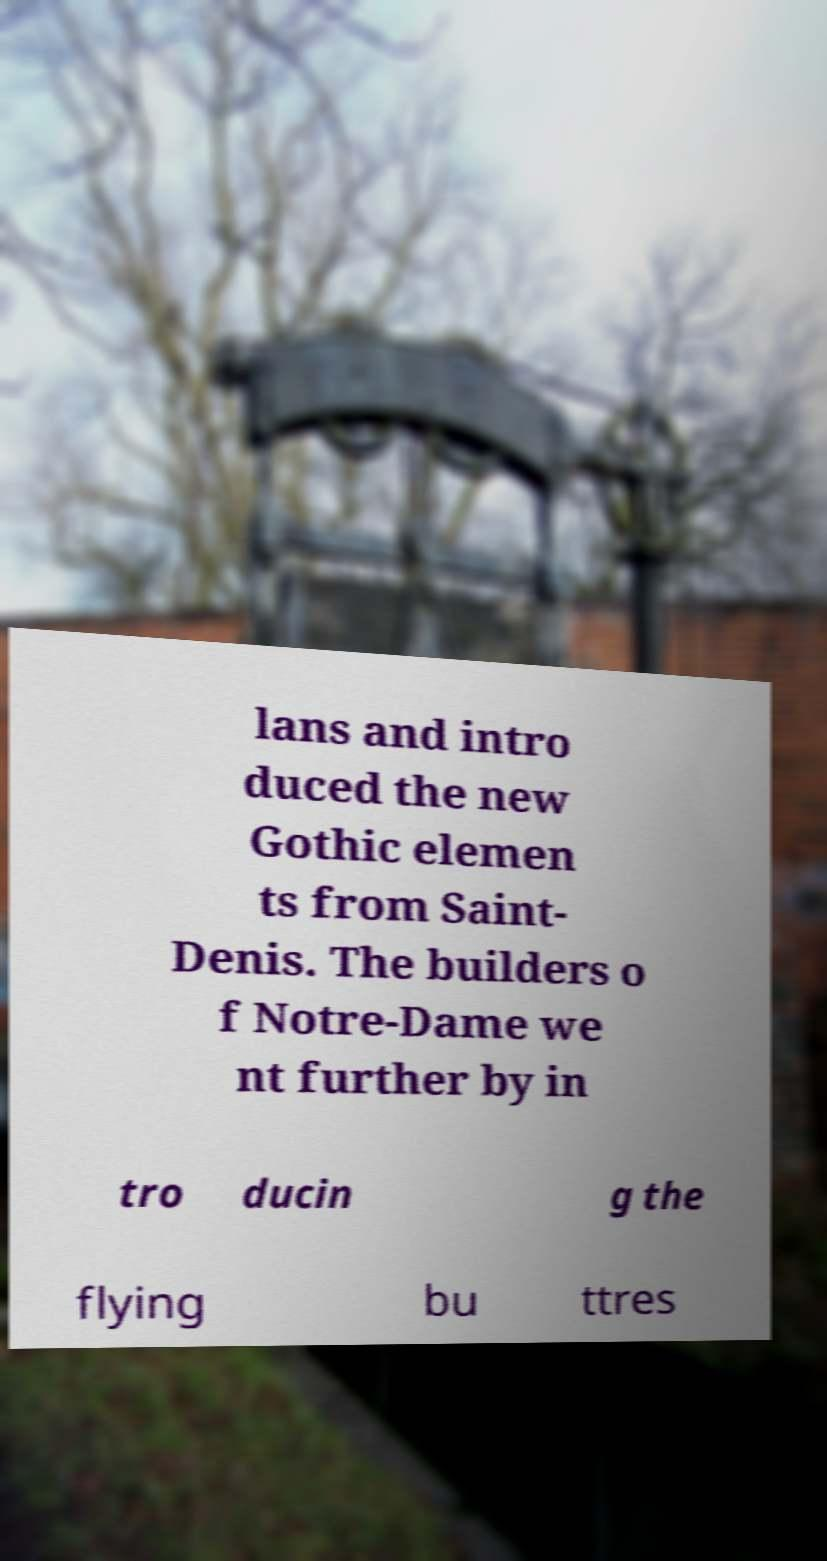What messages or text are displayed in this image? I need them in a readable, typed format. lans and intro duced the new Gothic elemen ts from Saint- Denis. The builders o f Notre-Dame we nt further by in tro ducin g the flying bu ttres 